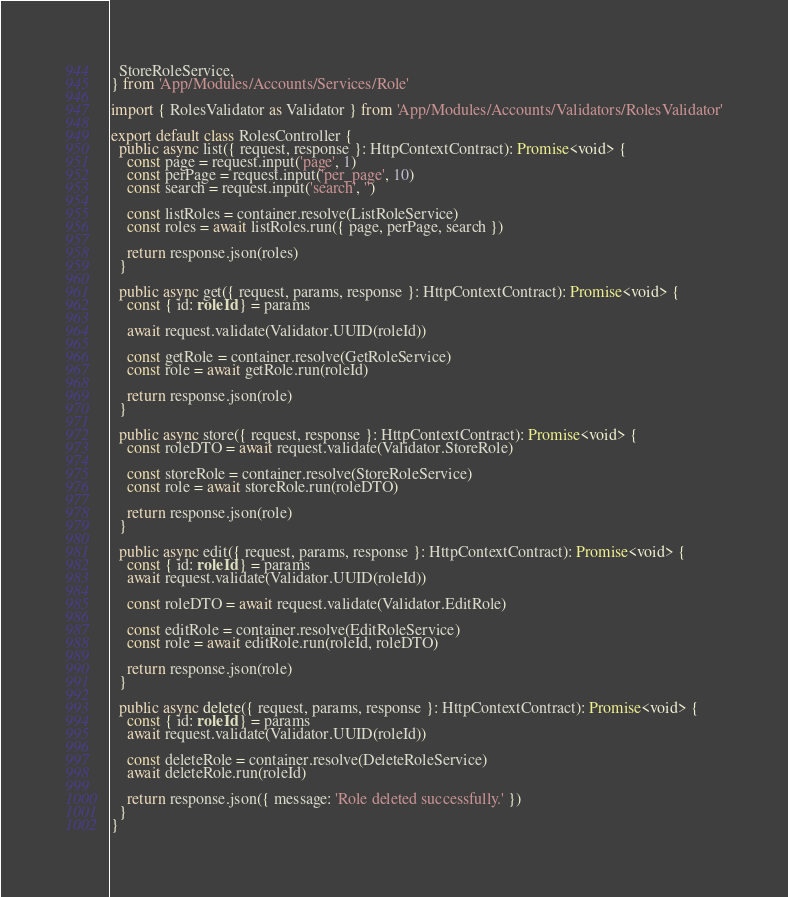<code> <loc_0><loc_0><loc_500><loc_500><_TypeScript_>  StoreRoleService,
} from 'App/Modules/Accounts/Services/Role'

import { RolesValidator as Validator } from 'App/Modules/Accounts/Validators/RolesValidator'

export default class RolesController {
  public async list({ request, response }: HttpContextContract): Promise<void> {
    const page = request.input('page', 1)
    const perPage = request.input('per_page', 10)
    const search = request.input('search', '')

    const listRoles = container.resolve(ListRoleService)
    const roles = await listRoles.run({ page, perPage, search })

    return response.json(roles)
  }

  public async get({ request, params, response }: HttpContextContract): Promise<void> {
    const { id: roleId } = params

    await request.validate(Validator.UUID(roleId))

    const getRole = container.resolve(GetRoleService)
    const role = await getRole.run(roleId)

    return response.json(role)
  }

  public async store({ request, response }: HttpContextContract): Promise<void> {
    const roleDTO = await request.validate(Validator.StoreRole)

    const storeRole = container.resolve(StoreRoleService)
    const role = await storeRole.run(roleDTO)

    return response.json(role)
  }

  public async edit({ request, params, response }: HttpContextContract): Promise<void> {
    const { id: roleId } = params
    await request.validate(Validator.UUID(roleId))

    const roleDTO = await request.validate(Validator.EditRole)

    const editRole = container.resolve(EditRoleService)
    const role = await editRole.run(roleId, roleDTO)

    return response.json(role)
  }

  public async delete({ request, params, response }: HttpContextContract): Promise<void> {
    const { id: roleId } = params
    await request.validate(Validator.UUID(roleId))

    const deleteRole = container.resolve(DeleteRoleService)
    await deleteRole.run(roleId)

    return response.json({ message: 'Role deleted successfully.' })
  }
}
</code> 